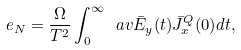<formula> <loc_0><loc_0><loc_500><loc_500>e _ { N } = \frac { \Omega } { T ^ { 2 } } \int _ { 0 } ^ { \infty } \ a v { \bar { E } _ { y } ( t ) \bar { J } _ { x } ^ { Q } ( 0 ) } d t ,</formula> 